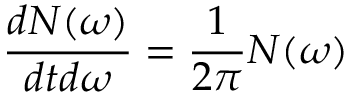<formula> <loc_0><loc_0><loc_500><loc_500>\frac { d N ( \omega ) } { d t d \omega } = \frac { 1 } { 2 \pi } N ( \omega )</formula> 